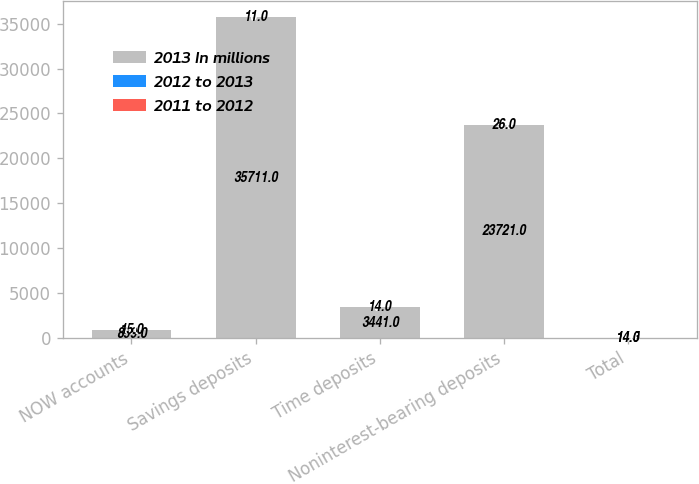Convert chart. <chart><loc_0><loc_0><loc_500><loc_500><stacked_bar_chart><ecel><fcel>NOW accounts<fcel>Savings deposits<fcel>Time deposits<fcel>Noninterest-bearing deposits<fcel>Total<nl><fcel>2013 In millions<fcel>899<fcel>35711<fcel>3441<fcel>23721<fcel>14.5<nl><fcel>2012 to 2013<fcel>8<fcel>10<fcel>18<fcel>9<fcel>8<nl><fcel>2011 to 2012<fcel>15<fcel>11<fcel>14<fcel>26<fcel>14<nl></chart> 